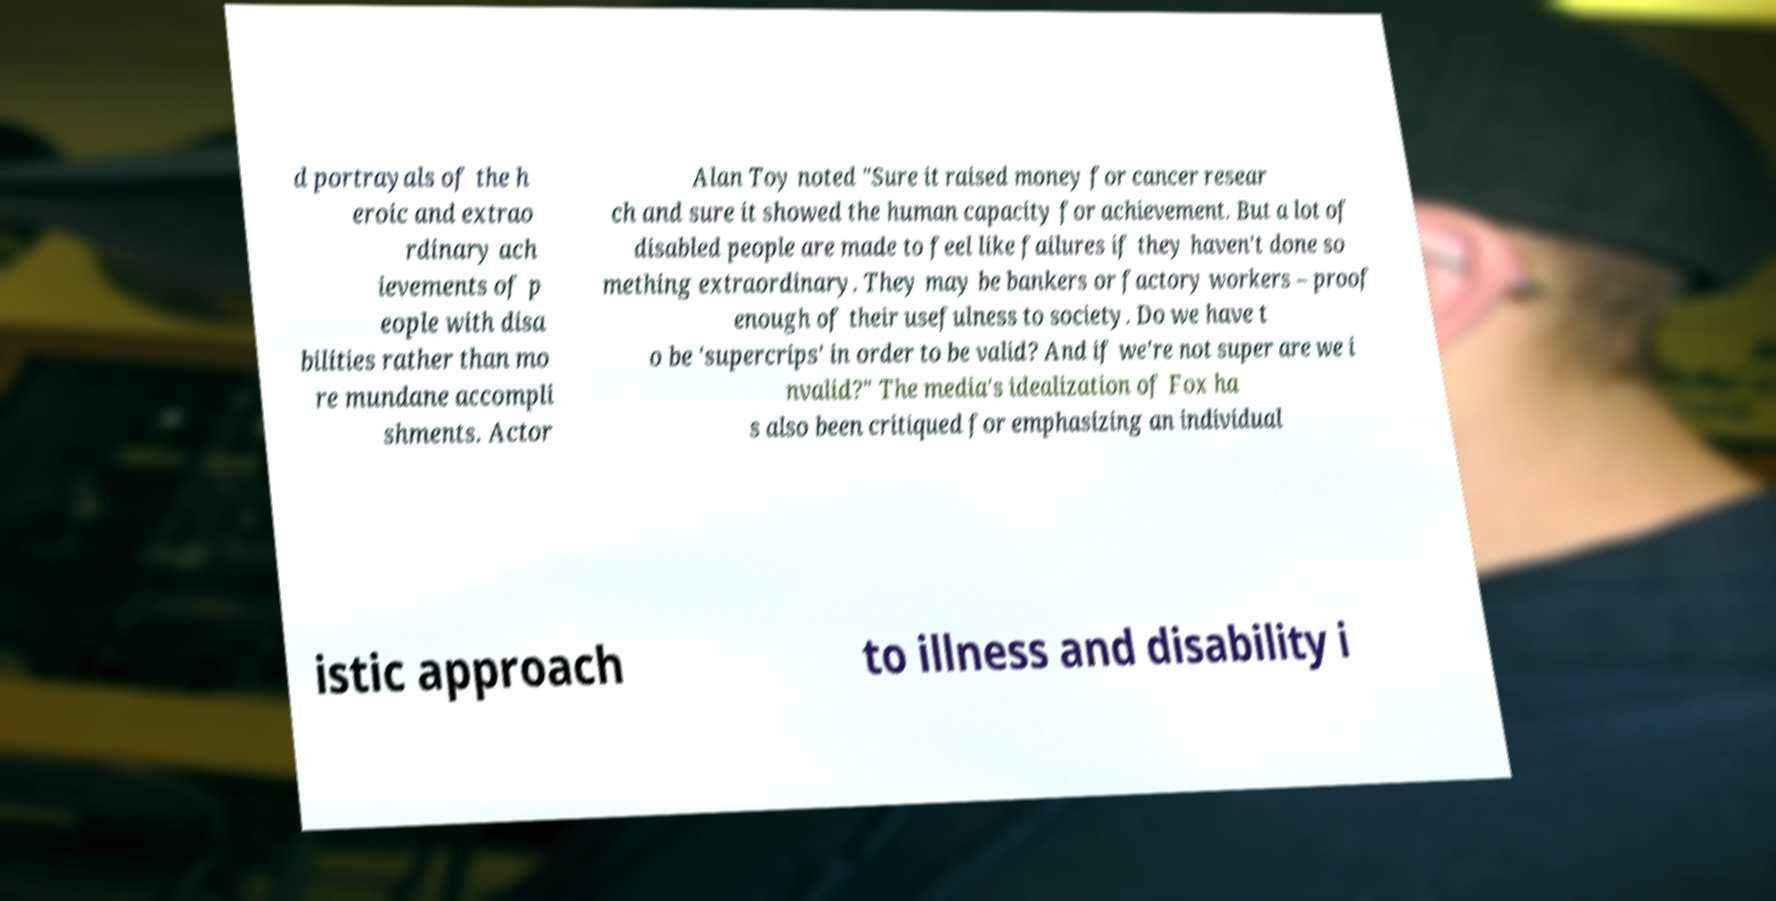What messages or text are displayed in this image? I need them in a readable, typed format. d portrayals of the h eroic and extrao rdinary ach ievements of p eople with disa bilities rather than mo re mundane accompli shments. Actor Alan Toy noted "Sure it raised money for cancer resear ch and sure it showed the human capacity for achievement. But a lot of disabled people are made to feel like failures if they haven't done so mething extraordinary. They may be bankers or factory workers – proof enough of their usefulness to society. Do we have t o be 'supercrips' in order to be valid? And if we're not super are we i nvalid?" The media's idealization of Fox ha s also been critiqued for emphasizing an individual istic approach to illness and disability i 